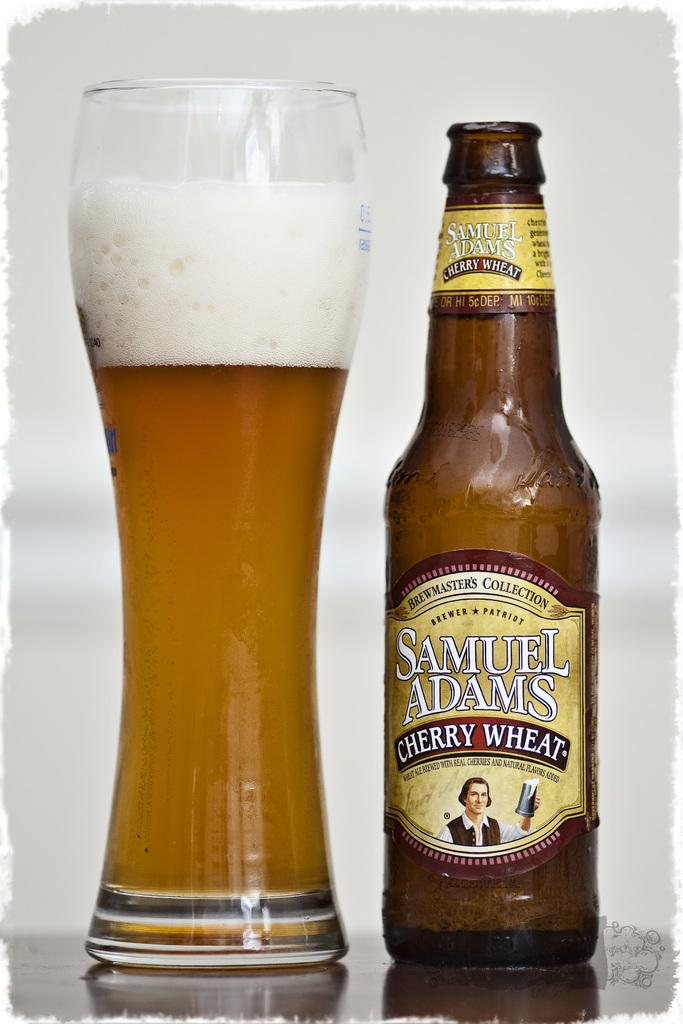<image>
Relay a brief, clear account of the picture shown. An empty Samuel Adams beer is next to the glass with the lager in it. 